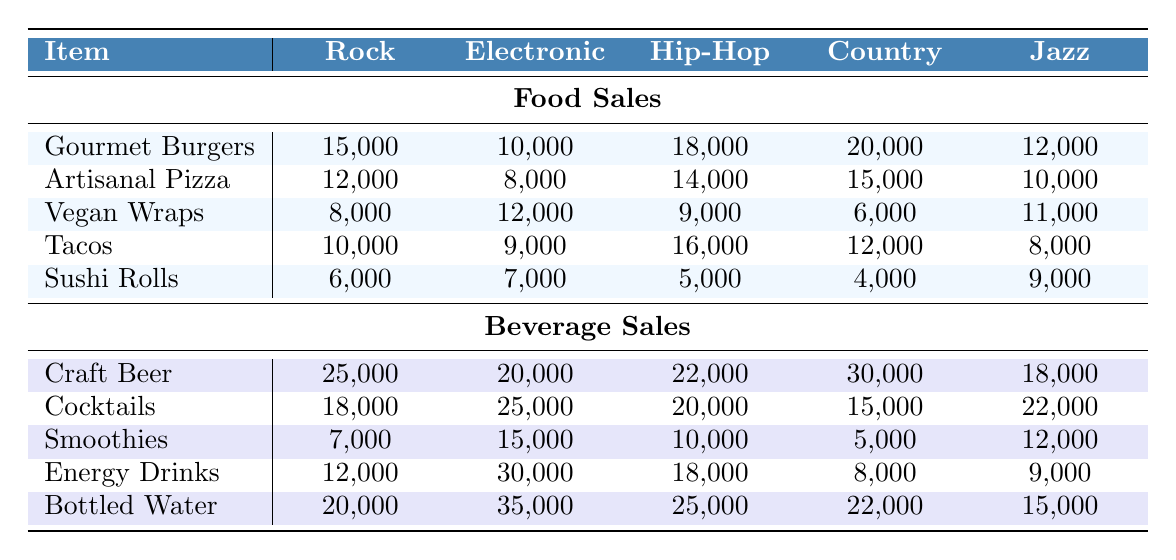What is the highest food sale among Gourmet Burgers across all genres? The highest food sale for Gourmet Burgers is found by comparing the values: 15,000 (Rock), 10,000 (Electronic), 18,000 (Hip-Hop), 20,000 (Country), and 12,000 (Jazz). The maximum value is 20,000 from the Country genre.
Answer: 20,000 Which beverage had the highest sales at the Electronic genre? Looking at the beverage sales for the Electronic genre, we have: Craft Beer (20,000), Cocktails (25,000), Smoothies (15,000), Energy Drinks (30,000), and Bottled Water (35,000). The highest sale is 35,000 from Bottled Water.
Answer: 35,000 What is the total food sales for the Hip-Hop genre? To find the total food sales for the Hip-Hop genre, sum the values: Gourmet Burgers (18,000) + Artisanal Pizza (14,000) + Vegan Wraps (9,000) + Tacos (16,000) + Sushi Rolls (5,000) = 62,000.
Answer: 62,000 Did the Country genre have higher beverage sales than the Rock genre? Comparing the two genres: Country has: Craft Beer (30,000), Cocktails (15,000), Smoothies (5,000), Energy Drinks (8,000), and Bottled Water (22,000), totaling 80,000. Rock has: Craft Beer (25,000), Cocktails (18,000), Smoothies (7,000), Energy Drinks (12,000), and Bottled Water (20,000), totaling 82,000. Since 80,000 < 82,000, the answer is no.
Answer: No What is the average sales of Vegan Wraps across all music genres? The sales of Vegan Wraps are: 8,000 (Rock), 12,000 (Electronic), 9,000 (Hip-Hop), 6,000 (Country), and 11,000 (Jazz). Adding these gives us 46,000. Dividing by the number of genres (5) gives 46,000 / 5 = 9,200.
Answer: 9,200 Which event had the lowest total beverage sales? Calculate the total beverage sales for each event: Coachella (25,000 + 18,000 + 7,000 + 12,000 + 20,000 = 82,000), Electric Daisy Carnival (20,000 + 25,000 + 15,000 + 30,000 + 35,000 = 125,000), Bonnaroo (22,000 + 20,000 + 10,000 + 18,000 + 25,000 = 105,000), Glastonbury (30,000 + 15,000 + 5,000 + 8,000 + 22,000 = 80,000), Lollapalooza (18,000 + 22,000 + 12,000 + 9,000 + 15,000 = 76,000). The event with the lowest total is Lollapalooza at 76,000.
Answer: Lollapalooza Which food item sold better in Jazz genre than in Rock genre? Comparing food sales between the Jazz and Rock genres: for Gourmet Burgers (12,000) > 15,000 (Rock), Artisanal Pizza (10,000) < 12,000 (Rock), Vegan Wraps (11,000) > 8,000 (Rock), Tacos (8,000) < 10,000 (Rock), and Sushi Rolls (9,000) < 6,000 (Rock). Therefore, Vegan Wraps is the only food item that sold better in the Jazz genre than in the Rock genre.
Answer: Vegan Wraps What is the difference in sales for Tacos between the highest and lowest festival genres? The highest Tacos sales is 16,000 from the Hip-Hop genre and the lowest is 8,000 from the Jazz genre. The difference is calculated as 16,000 - 8,000 = 8,000.
Answer: 8,000 Which genre had the highest total sales for both food and beverages combined? Compute the total for each genre: Rock (82,000), Electronic (125,000), Hip-Hop (105,000), Country (80,000), and Jazz (75,000). The highest total sales is 125,000 for the Electronic genre.
Answer: Electronic 